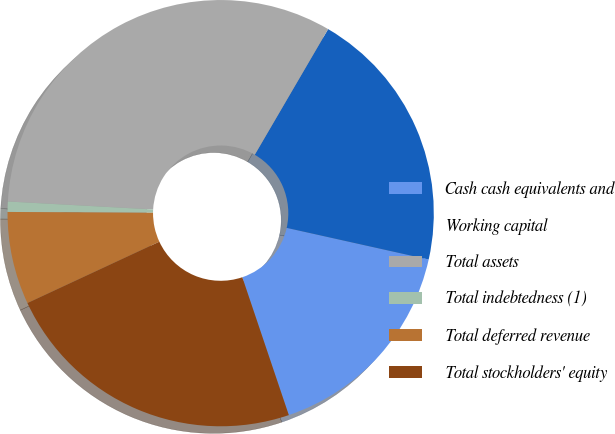Convert chart. <chart><loc_0><loc_0><loc_500><loc_500><pie_chart><fcel>Cash cash equivalents and<fcel>Working capital<fcel>Total assets<fcel>Total indebtedness (1)<fcel>Total deferred revenue<fcel>Total stockholders' equity<nl><fcel>16.33%<fcel>20.08%<fcel>32.54%<fcel>0.78%<fcel>7.02%<fcel>23.25%<nl></chart> 